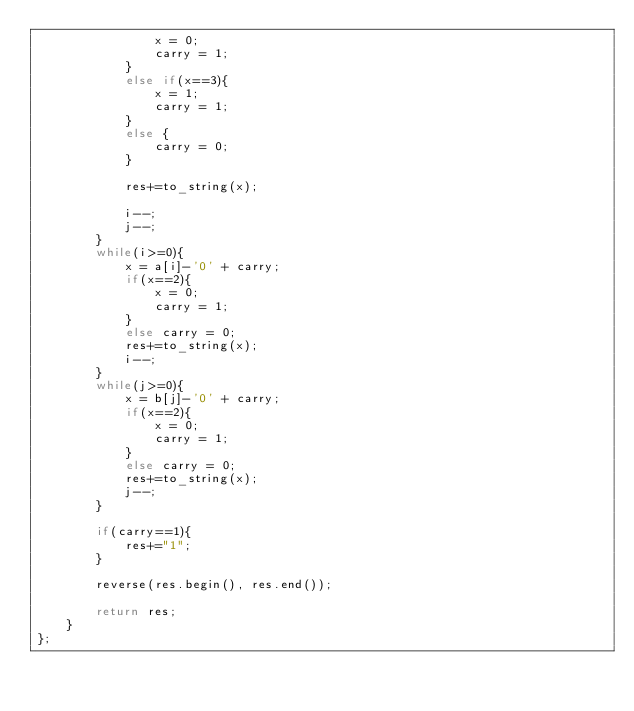Convert code to text. <code><loc_0><loc_0><loc_500><loc_500><_C++_>                x = 0;
                carry = 1;
            }
            else if(x==3){
                x = 1;
                carry = 1;
            }
            else {
                carry = 0;
            }
            
            res+=to_string(x);
            
            i--;
            j--;
        }
        while(i>=0){
            x = a[i]-'0' + carry;
            if(x==2){
                x = 0;
                carry = 1;
            }
            else carry = 0;
            res+=to_string(x);
            i--;
        }
        while(j>=0){
            x = b[j]-'0' + carry;
            if(x==2){
                x = 0;
                carry = 1;
            }
            else carry = 0;
            res+=to_string(x);
            j--;
        }
        
        if(carry==1){
            res+="1";
        }
        
        reverse(res.begin(), res.end());
        
        return res;
    }
};
</code> 